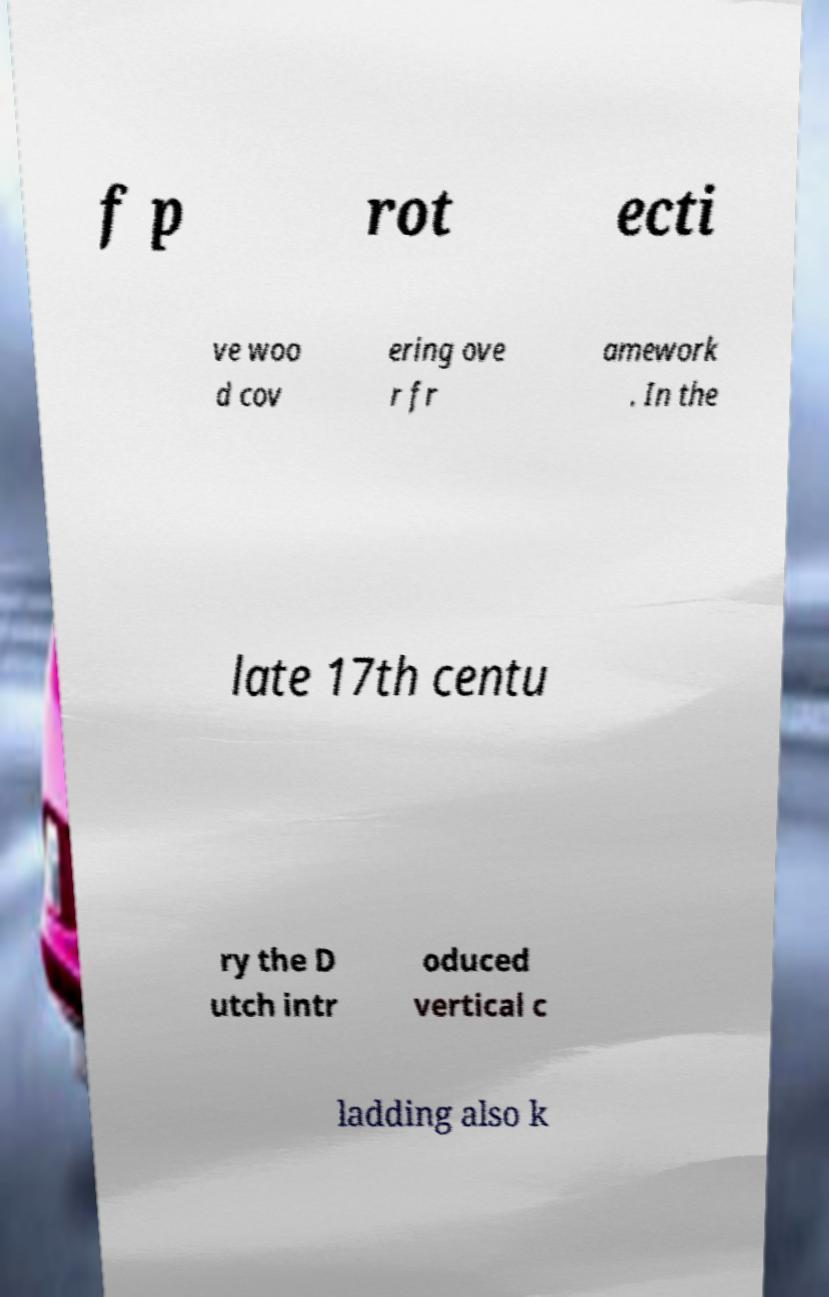Can you read and provide the text displayed in the image?This photo seems to have some interesting text. Can you extract and type it out for me? f p rot ecti ve woo d cov ering ove r fr amework . In the late 17th centu ry the D utch intr oduced vertical c ladding also k 